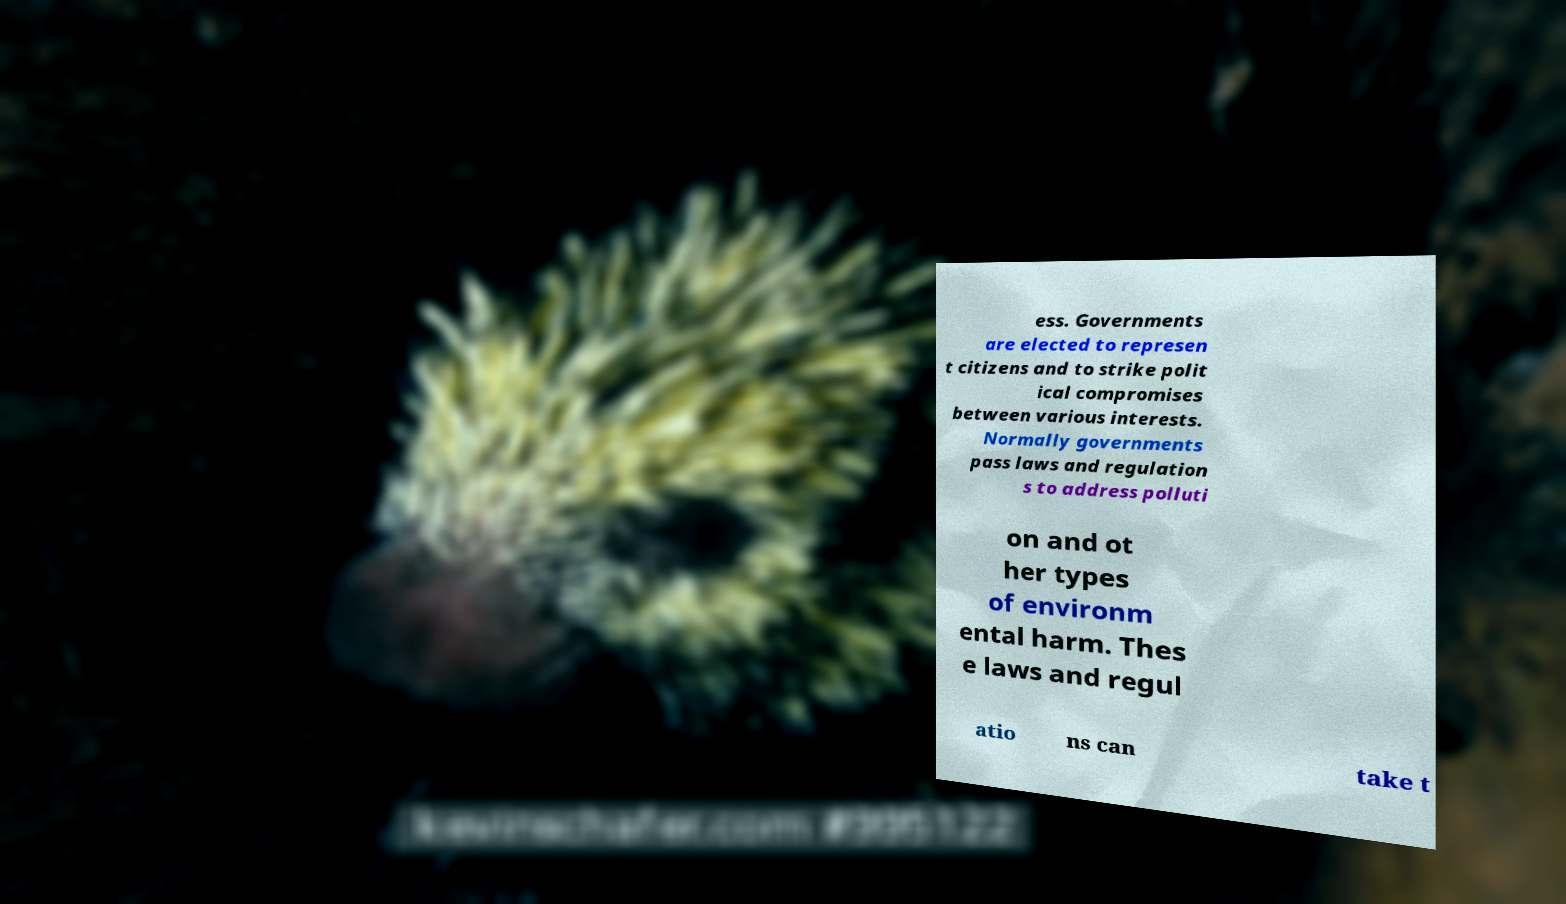What messages or text are displayed in this image? I need them in a readable, typed format. ess. Governments are elected to represen t citizens and to strike polit ical compromises between various interests. Normally governments pass laws and regulation s to address polluti on and ot her types of environm ental harm. Thes e laws and regul atio ns can take t 